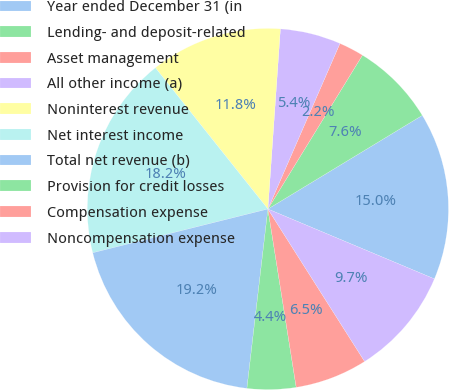Convert chart. <chart><loc_0><loc_0><loc_500><loc_500><pie_chart><fcel>Year ended December 31 (in<fcel>Lending- and deposit-related<fcel>Asset management<fcel>All other income (a)<fcel>Noninterest revenue<fcel>Net interest income<fcel>Total net revenue (b)<fcel>Provision for credit losses<fcel>Compensation expense<fcel>Noncompensation expense<nl><fcel>15.0%<fcel>7.55%<fcel>2.24%<fcel>5.43%<fcel>11.81%<fcel>18.19%<fcel>19.25%<fcel>4.36%<fcel>6.49%<fcel>9.68%<nl></chart> 